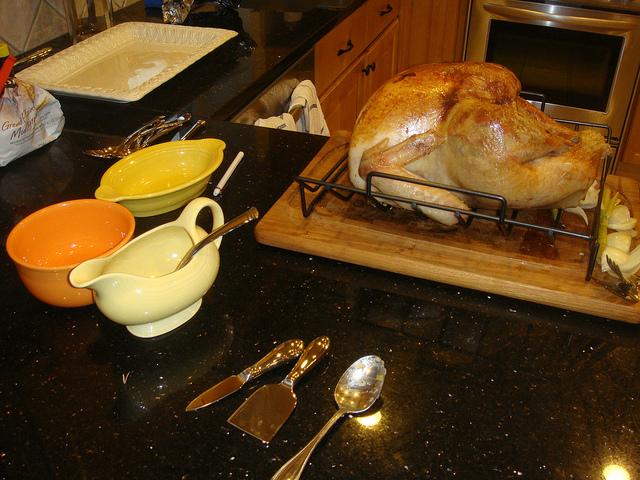Has the chicken been carved?
Short answer required. No. What color is the countertop?
Be succinct. Black. Are all of the utensils on the counter top facing the same direction?
Give a very brief answer. No. 